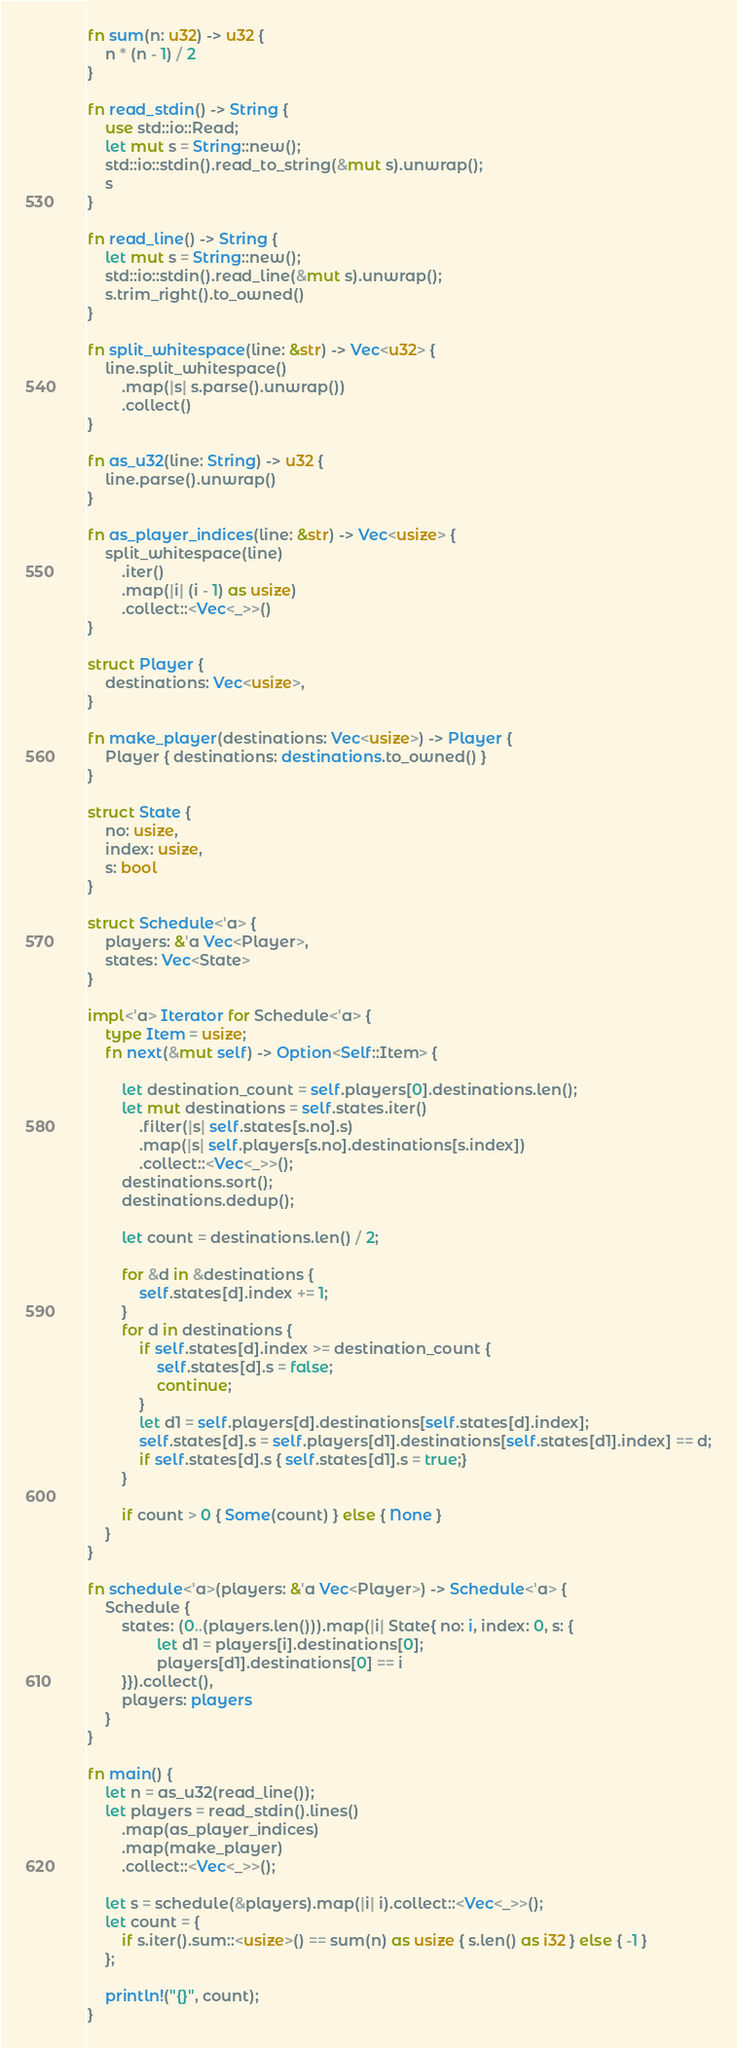Convert code to text. <code><loc_0><loc_0><loc_500><loc_500><_Rust_>fn sum(n: u32) -> u32 {
    n * (n - 1) / 2
}
 
fn read_stdin() -> String {
    use std::io::Read;
    let mut s = String::new();
    std::io::stdin().read_to_string(&mut s).unwrap();
    s
}
 
fn read_line() -> String {
    let mut s = String::new();
    std::io::stdin().read_line(&mut s).unwrap();
    s.trim_right().to_owned()
}
 
fn split_whitespace(line: &str) -> Vec<u32> {
    line.split_whitespace()
        .map(|s| s.parse().unwrap())
        .collect()
}
 
fn as_u32(line: String) -> u32 {
    line.parse().unwrap()
}
 
fn as_player_indices(line: &str) -> Vec<usize> {
    split_whitespace(line)
        .iter()
        .map(|i| (i - 1) as usize)
        .collect::<Vec<_>>()
}
 
struct Player {
    destinations: Vec<usize>,
}
 
fn make_player(destinations: Vec<usize>) -> Player {
    Player { destinations: destinations.to_owned() }
}
 
struct State {
    no: usize,
    index: usize,
    s: bool
}
 
struct Schedule<'a> {
    players: &'a Vec<Player>,
    states: Vec<State>
}
 
impl<'a> Iterator for Schedule<'a> {
    type Item = usize;
    fn next(&mut self) -> Option<Self::Item> {
        
        let destination_count = self.players[0].destinations.len();
        let mut destinations = self.states.iter()
            .filter(|s| self.states[s.no].s)
            .map(|s| self.players[s.no].destinations[s.index])
            .collect::<Vec<_>>();
        destinations.sort();
        destinations.dedup();  
        
        let count = destinations.len() / 2;
        
        for &d in &destinations {
            self.states[d].index += 1;
        }
        for d in destinations {
            if self.states[d].index >= destination_count {
                self.states[d].s = false;
                continue;
            }
            let d1 = self.players[d].destinations[self.states[d].index];
            self.states[d].s = self.players[d1].destinations[self.states[d1].index] == d;
            if self.states[d].s { self.states[d1].s = true;}
        }
        
        if count > 0 { Some(count) } else { None }
    }
}
 
fn schedule<'a>(players: &'a Vec<Player>) -> Schedule<'a> {
    Schedule {
        states: (0..(players.len())).map(|i| State{ no: i, index: 0, s: {
                let d1 = players[i].destinations[0];
                players[d1].destinations[0] == i
        }}).collect(),
        players: players
    }
}
 
fn main() {
    let n = as_u32(read_line());
    let players = read_stdin().lines()
        .map(as_player_indices)
        .map(make_player)
        .collect::<Vec<_>>();
        
    let s = schedule(&players).map(|i| i).collect::<Vec<_>>();
    let count = {
        if s.iter().sum::<usize>() == sum(n) as usize { s.len() as i32 } else { -1 }
    };
 
    println!("{}", count);
}</code> 